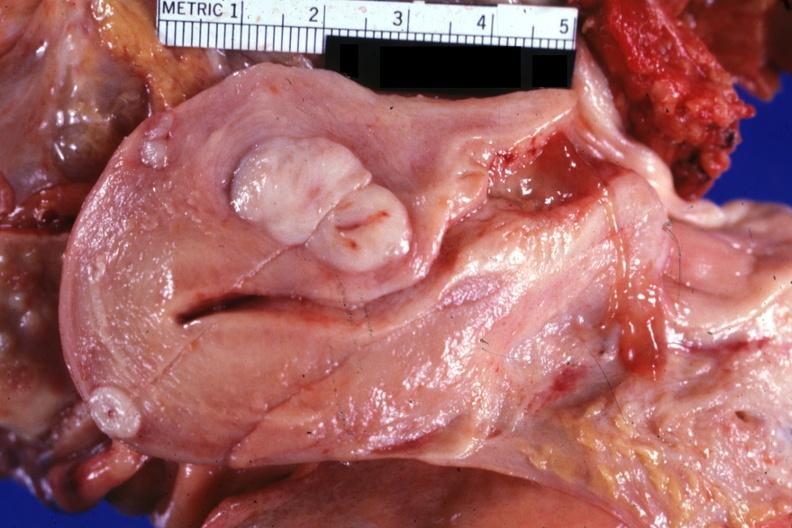what is present?
Answer the question using a single word or phrase. Leiomyoma 